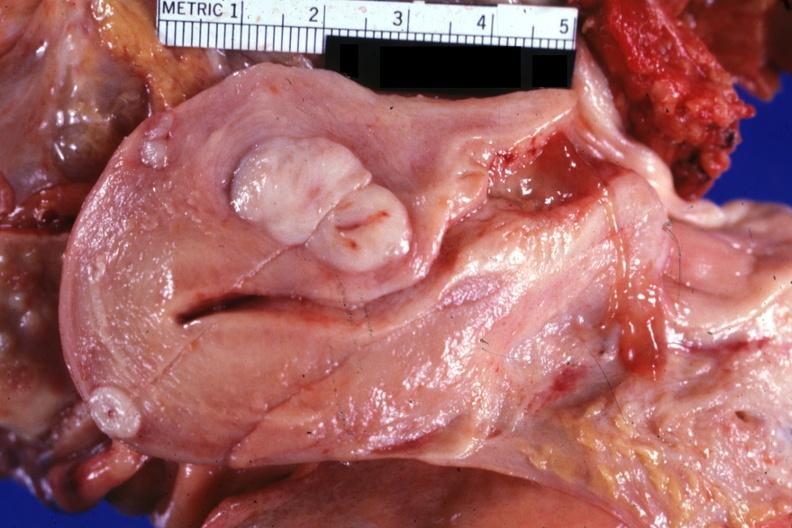what is present?
Answer the question using a single word or phrase. Leiomyoma 